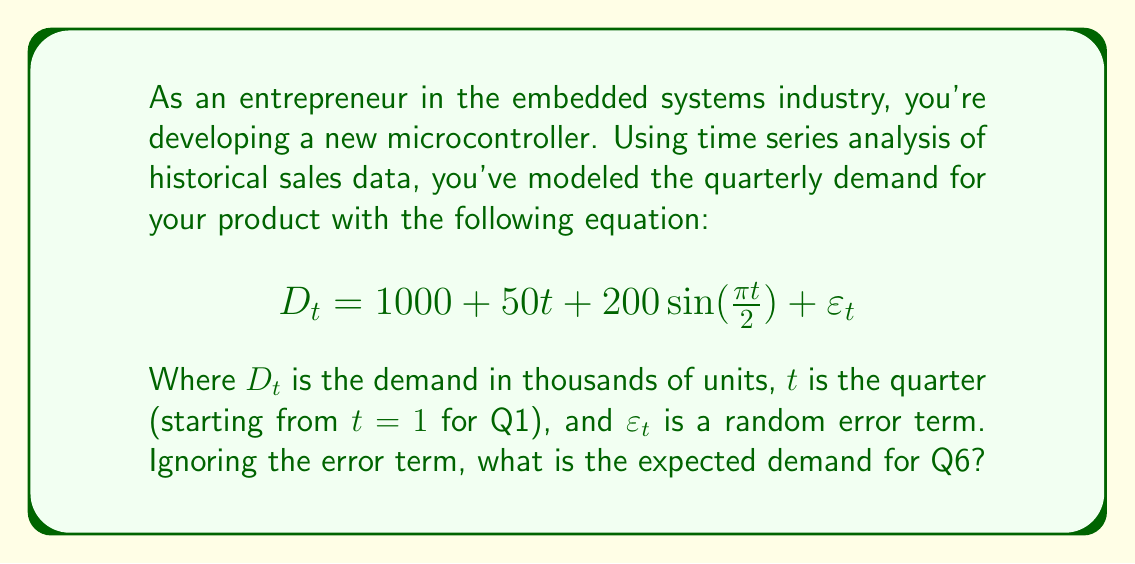Solve this math problem. To solve this problem, we'll follow these steps:

1) Identify the components of the time series model:
   - Trend component: $1000 + 50t$
   - Seasonal component: $200 \sin(\frac{\pi t}{2})$
   - $\varepsilon_t$ is ignored as per the question

2) Substitute $t=6$ into the equation:

   $$D_6 = 1000 + 50(6) + 200 \sin(\frac{\pi 6}{2})$$

3) Calculate the trend component:
   $1000 + 50(6) = 1000 + 300 = 1300$

4) Calculate the seasonal component:
   $200 \sin(\frac{\pi 6}{2}) = 200 \sin(3\pi) = 0$
   
   Note: $\sin(3\pi) = 0$ because sine has a period of $2\pi$, and $3\pi$ is equivalent to $\pi$ in the sine function, which equals 0.

5) Sum the components:
   $D_6 = 1300 + 0 = 1300$

Therefore, the expected demand for Q6 is 1300 thousand units, or 1.3 million units.
Answer: 1.3 million units 